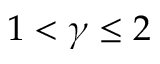<formula> <loc_0><loc_0><loc_500><loc_500>1 < \gamma \leq 2</formula> 